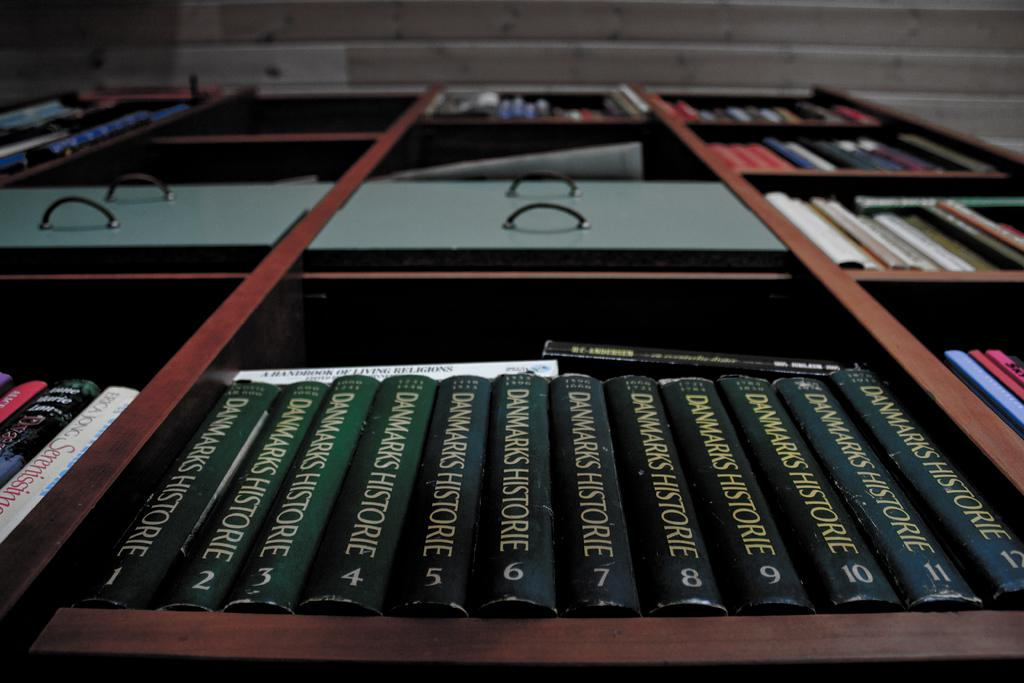<image>
Provide a brief description of the given image. A wooden divider with books which one is titled Danmarks Historie by numbered volumes. 